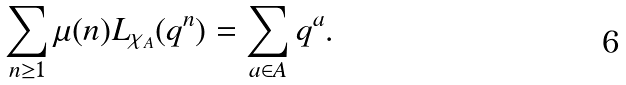Convert formula to latex. <formula><loc_0><loc_0><loc_500><loc_500>\sum _ { n \geq 1 } \mu ( n ) L _ { \chi _ { A } } ( q ^ { n } ) = \sum _ { a \in A } q ^ { a } .</formula> 